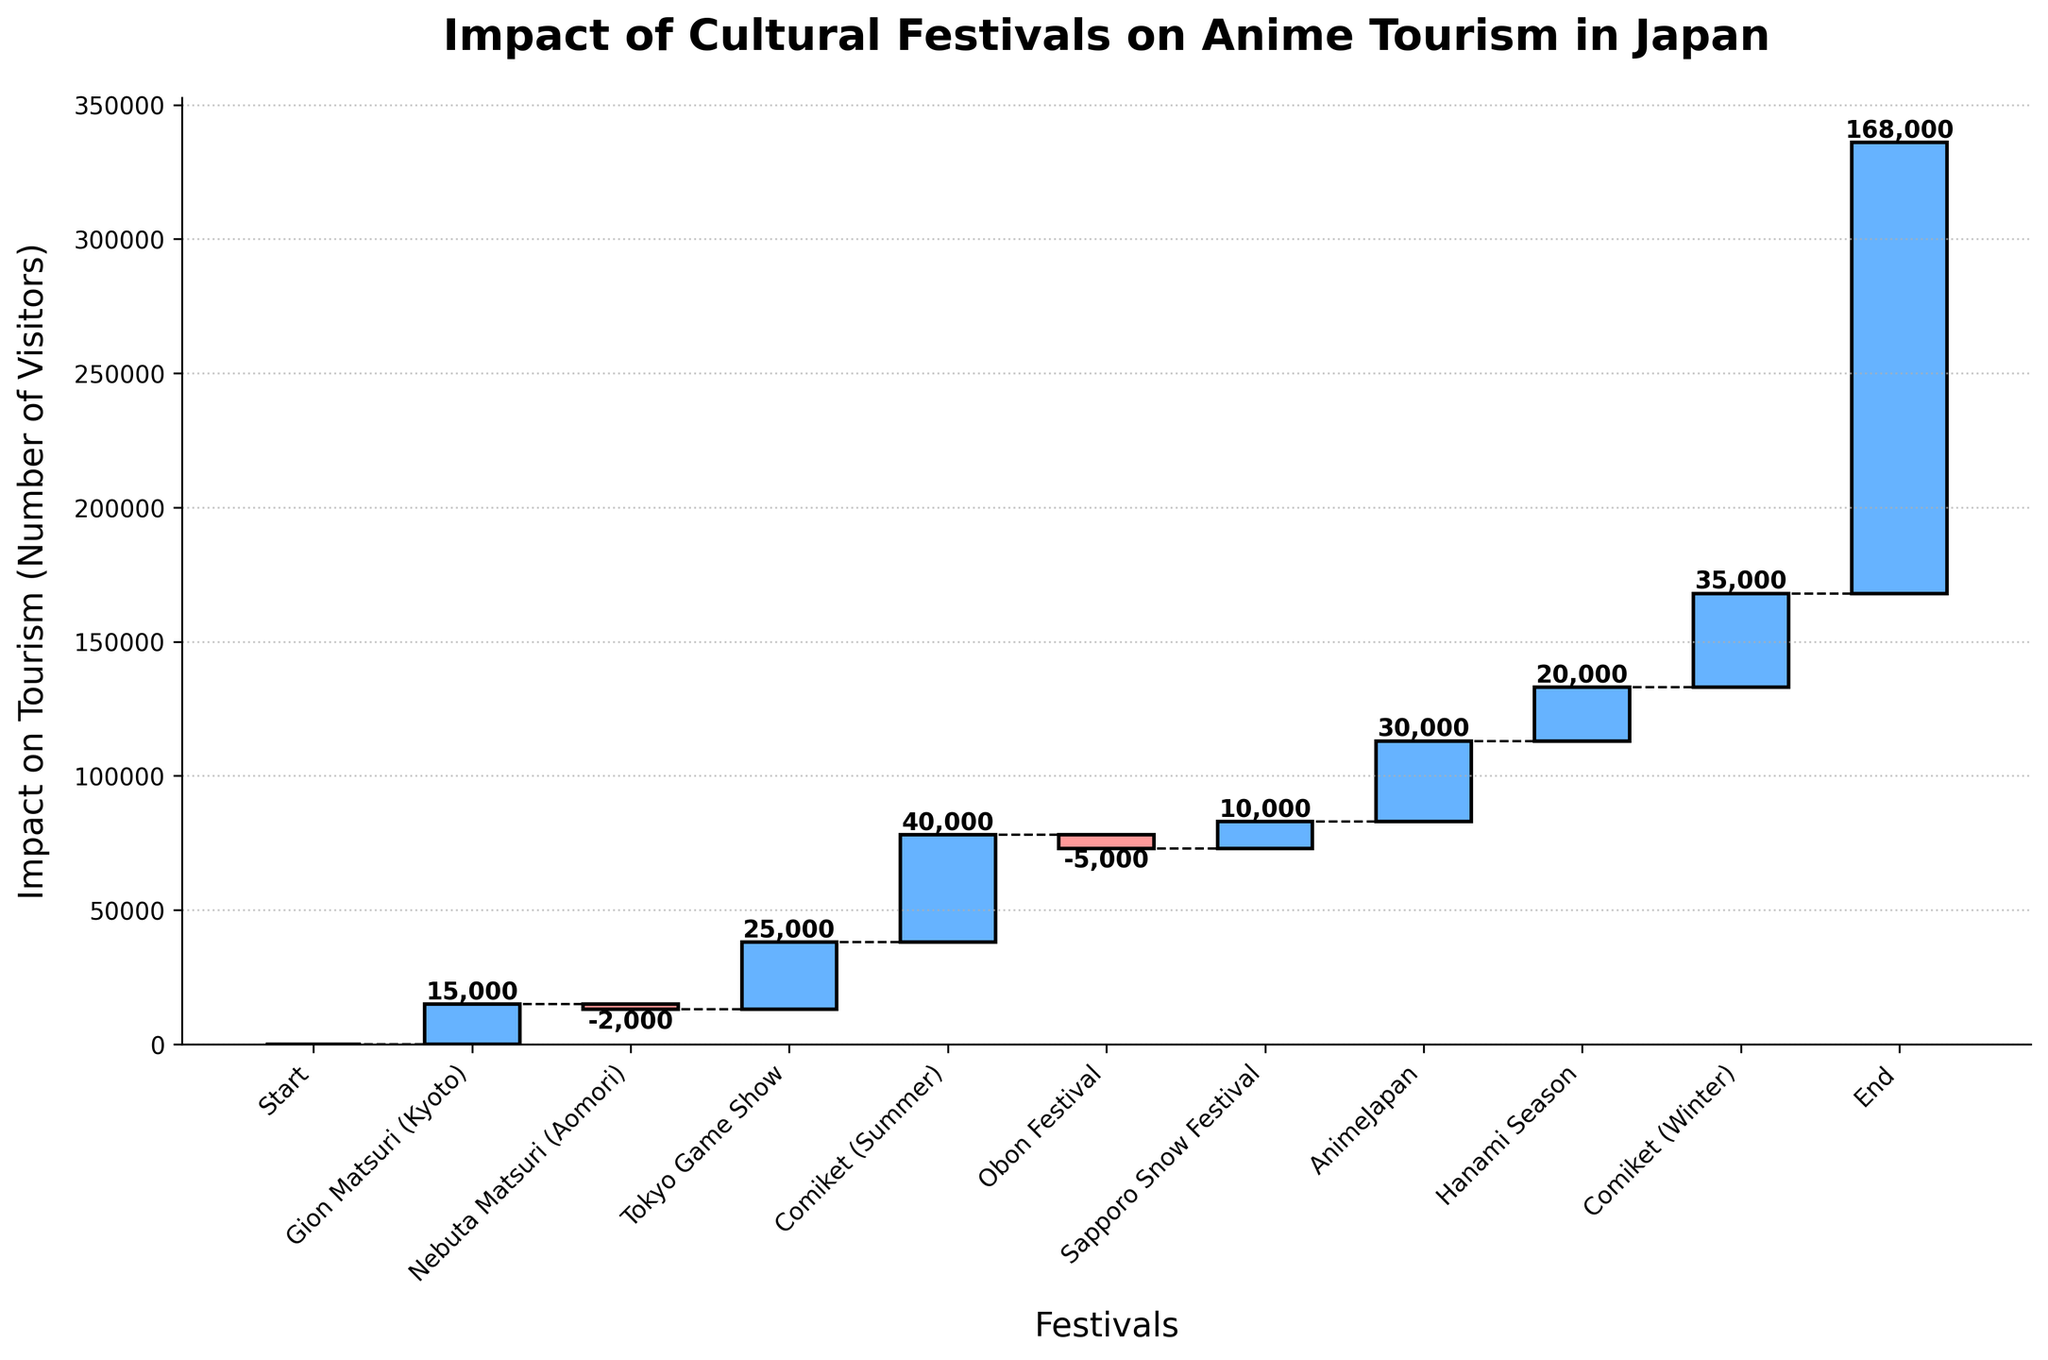How many cultural festivals are included in the chart? The chart presents a series of bars representing the impact on anime tourism for various cultural festivals. By counting the number of labeled bars, we can determine the number of festivals shown.
Answer: 10 What is the total impact on tourism by the end of the period depicted in the chart? To find the total impact, we look at the cumulative value at the end of the chart. The final bar 'End' shows this cumulative impact.
Answer: 168,000 Which festival has the highest positive impact on anime tourism? To determine this, we look for the bar with the highest value above the baseline. The tallest positive bar corresponds to the festival with the highest impact.
Answer: Comiket (Summer) What was the cumulative impact on tourism after AnimeJapan? Cumulative impact can be read directly from the label on the bar of 'AnimeJapan'.
Answer: 132,000 How does the impact of the Obon Festival compare with the impact of the Nebuta Matsuri? By comparing the heights and values of the respective bars, we can see the relative magnitude of their impacts. Obon has a negative value of -5,000, while Nebuta Matsuri has -2,000.
Answer: Obon Festival has a more negative impact Which festival resulted in the first negative impact, and what was its value? The first downward step in the cumulative line indicates the first negative impact. By checking the festival labels in this region, we can find the first negative impact and its value.
Answer: Nebuta Matsuri, -2,000 What is the aggregate positive impact of all festivals on tourism? To find this, sum up all the positive impacts from the chart: 15,000 + 25,000 + 40,000 + 10,000 + 30,000 + 20,000 + 35,000.
Answer: 175,000 What is the aggregate negative impact of all festivals on tourism? To find this, sum up all the negative impacts from the chart: -2,000 + -5,000.
Answer: -7,000 During which festival does the greatest jump in tourism impact happen? The largest jump corresponds to the festival with the highest positive impact value, which is represented by the tallest bar above the baseline.
Answer: Comiket (Summer) How much did the tourism impact increase from the start to after the Tokyo Game Show? The increase is the sum of positive impacts minus any negative impacts up to that point. The cumulative impact after Tokyo Game Show is 40,000 (15,000 from Gion Matsuri + 25,000 from Tokyo Game Show).
Answer: 40,000 